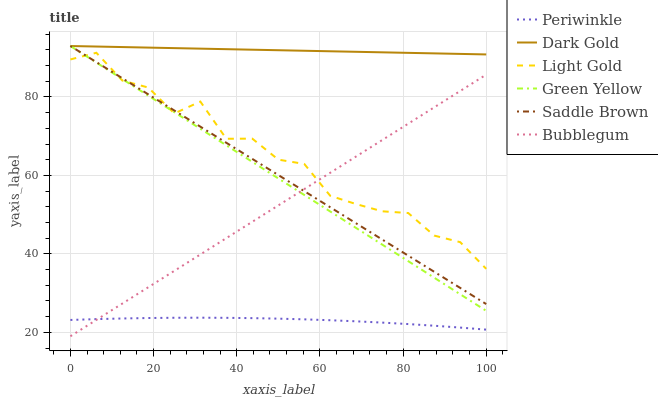Does Bubblegum have the minimum area under the curve?
Answer yes or no. No. Does Bubblegum have the maximum area under the curve?
Answer yes or no. No. Is Bubblegum the smoothest?
Answer yes or no. No. Is Bubblegum the roughest?
Answer yes or no. No. Does Periwinkle have the lowest value?
Answer yes or no. No. Does Bubblegum have the highest value?
Answer yes or no. No. Is Periwinkle less than Green Yellow?
Answer yes or no. Yes. Is Green Yellow greater than Periwinkle?
Answer yes or no. Yes. Does Periwinkle intersect Green Yellow?
Answer yes or no. No. 